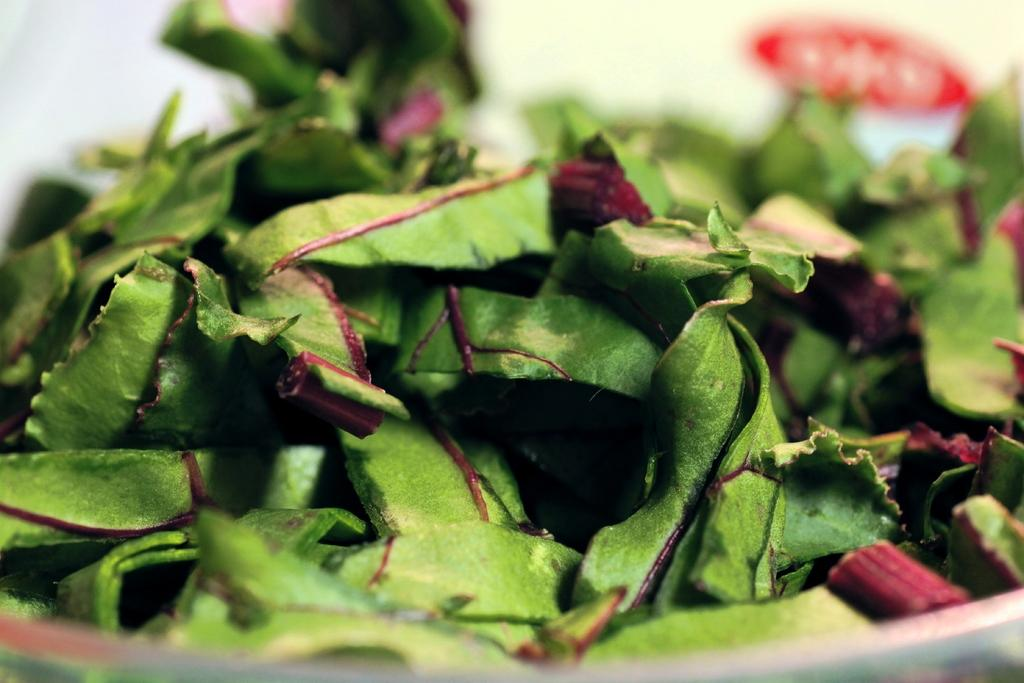What type of vegetation can be seen in the image? There are leaves in the image. Can you describe the background of the image? The background of the image is blurred. What type of cable is visible on the page in the image? There is no cable or page present in the image; it only features leaves and a blurred background. 